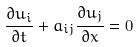<formula> <loc_0><loc_0><loc_500><loc_500>\frac { \partial u _ { i } } { \partial t } + a _ { i j } \frac { \partial u _ { j } } { \partial x } = 0</formula> 